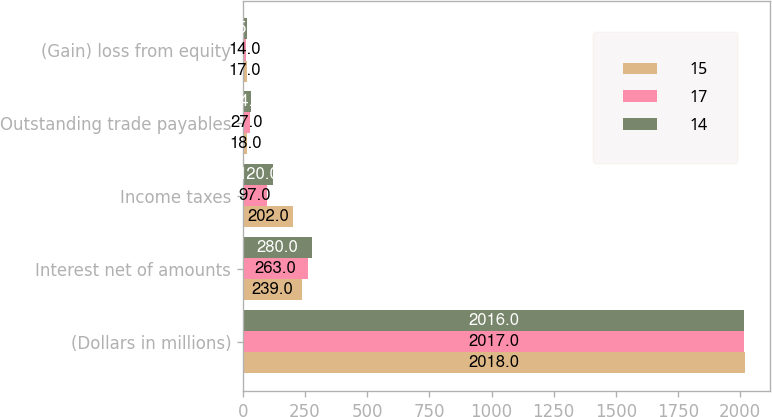Convert chart. <chart><loc_0><loc_0><loc_500><loc_500><stacked_bar_chart><ecel><fcel>(Dollars in millions)<fcel>Interest net of amounts<fcel>Income taxes<fcel>Outstanding trade payables<fcel>(Gain) loss from equity<nl><fcel>15<fcel>2018<fcel>239<fcel>202<fcel>18<fcel>17<nl><fcel>17<fcel>2017<fcel>263<fcel>97<fcel>27<fcel>14<nl><fcel>14<fcel>2016<fcel>280<fcel>120<fcel>34<fcel>15<nl></chart> 